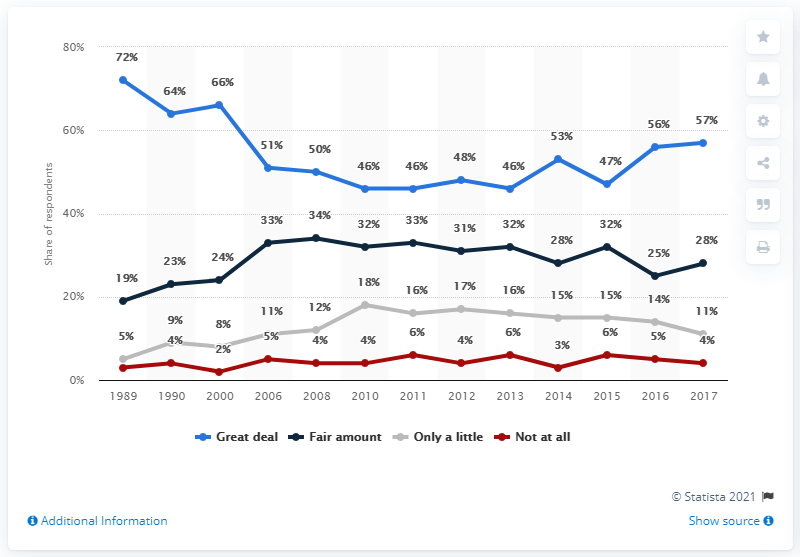Draw attention to some important aspects in this diagram. The survey began in 1989. 